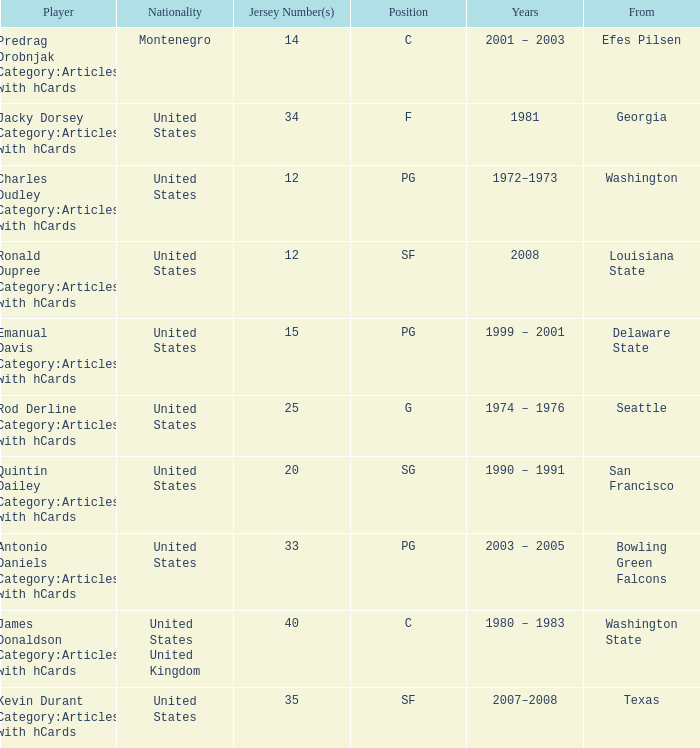What is the lowest jersey number of a player from louisiana state? 12.0. Can you give me this table as a dict? {'header': ['Player', 'Nationality', 'Jersey Number(s)', 'Position', 'Years', 'From'], 'rows': [['Predrag Drobnjak Category:Articles with hCards', 'Montenegro', '14', 'C', '2001 – 2003', 'Efes Pilsen'], ['Jacky Dorsey Category:Articles with hCards', 'United States', '34', 'F', '1981', 'Georgia'], ['Charles Dudley Category:Articles with hCards', 'United States', '12', 'PG', '1972–1973', 'Washington'], ['Ronald Dupree Category:Articles with hCards', 'United States', '12', 'SF', '2008', 'Louisiana State'], ['Emanual Davis Category:Articles with hCards', 'United States', '15', 'PG', '1999 – 2001', 'Delaware State'], ['Rod Derline Category:Articles with hCards', 'United States', '25', 'G', '1974 – 1976', 'Seattle'], ['Quintin Dailey Category:Articles with hCards', 'United States', '20', 'SG', '1990 – 1991', 'San Francisco'], ['Antonio Daniels Category:Articles with hCards', 'United States', '33', 'PG', '2003 – 2005', 'Bowling Green Falcons'], ['James Donaldson Category:Articles with hCards', 'United States United Kingdom', '40', 'C', '1980 – 1983', 'Washington State'], ['Kevin Durant Category:Articles with hCards', 'United States', '35', 'SF', '2007–2008', 'Texas']]} 